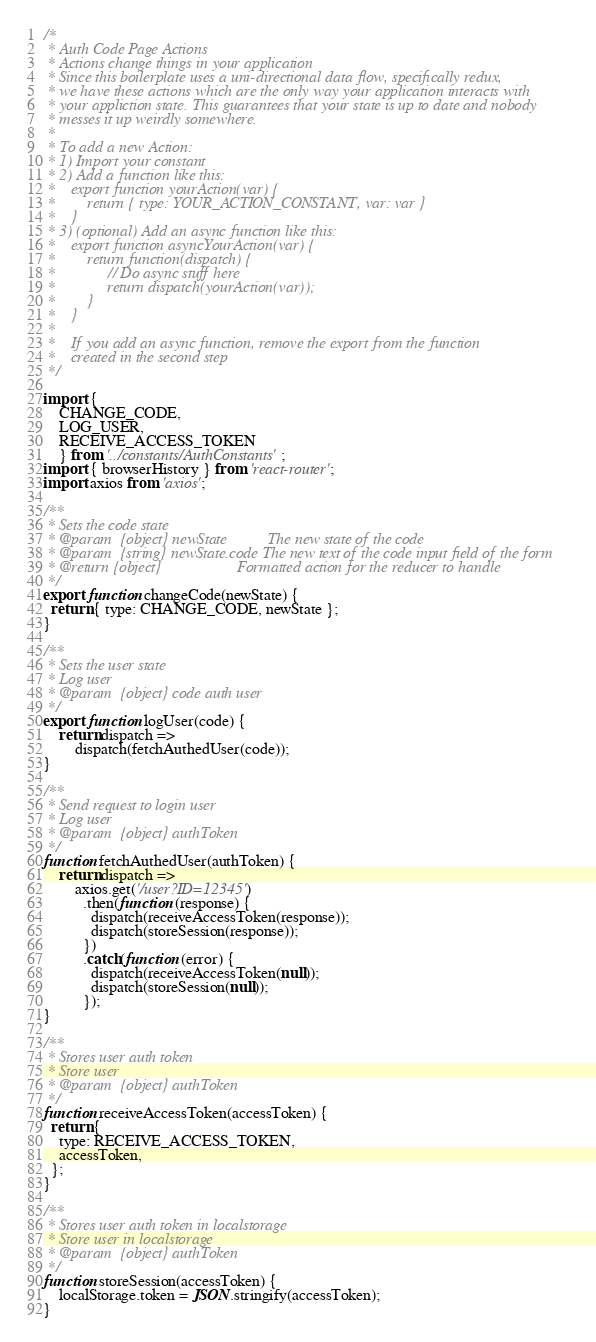Convert code to text. <code><loc_0><loc_0><loc_500><loc_500><_JavaScript_>
/*
 * Auth Code Page Actions
 * Actions change things in your application
 * Since this boilerplate uses a uni-directional data flow, specifically redux,
 * we have these actions which are the only way your application interacts with
 * your appliction state. This guarantees that your state is up to date and nobody
 * messes it up weirdly somewhere.
 *
 * To add a new Action:
 * 1) Import your constant
 * 2) Add a function like this:
 *    export function yourAction(var) {
 *        return { type: YOUR_ACTION_CONSTANT, var: var }
 *    }
 * 3) (optional) Add an async function like this:
 *    export function asyncYourAction(var) {
 *        return function(dispatch) {
 *             // Do async stuff here
 *             return dispatch(yourAction(var));
 *        }
 *    }
 *
 *    If you add an async function, remove the export from the function
 *    created in the second step
 */

import { 
	CHANGE_CODE,
	LOG_USER,
	RECEIVE_ACCESS_TOKEN
	} from '../constants/AuthConstants';
import { browserHistory } from 'react-router';
import axios from 'axios';

/**
 * Sets the code state
 * @param  {object} newState          The new state of the code
 * @param  {string} newState.code The new text of the code input field of the form
 * @return {object}                   Formatted action for the reducer to handle
 */
export function changeCode(newState) {
  return { type: CHANGE_CODE, newState };
}

/**
 * Sets the user state
 * Log user 
 * @param  {object} code auth user
 */
export function logUser(code) {
	return dispatch =>
		dispatch(fetchAuthedUser(code));
}

/**
 * Send request to login user
 * Log user 
 * @param  {object} authToken
 */
function fetchAuthedUser(authToken) {
	return dispatch =>
		axios.get('/user?ID=12345')
		  .then(function (response) {
		    dispatch(receiveAccessToken(response));
		    dispatch(storeSession(response));
		  })
		  .catch(function (error) {
		    dispatch(receiveAccessToken(null));
		    dispatch(storeSession(null));
		  });
}

/**
 * Stores user auth token
 * Store user 
 * @param  {object} authToken
 */
function receiveAccessToken(accessToken) {
  return {
    type: RECEIVE_ACCESS_TOKEN,
    accessToken,
  };
}

/**
 * Stores user auth token in localstorage
 * Store user in localstorage
 * @param  {object} authToken
 */
function storeSession(accessToken) {
	localStorage.token = JSON.stringify(accessToken);
}
</code> 